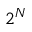Convert formula to latex. <formula><loc_0><loc_0><loc_500><loc_500>2 ^ { N }</formula> 